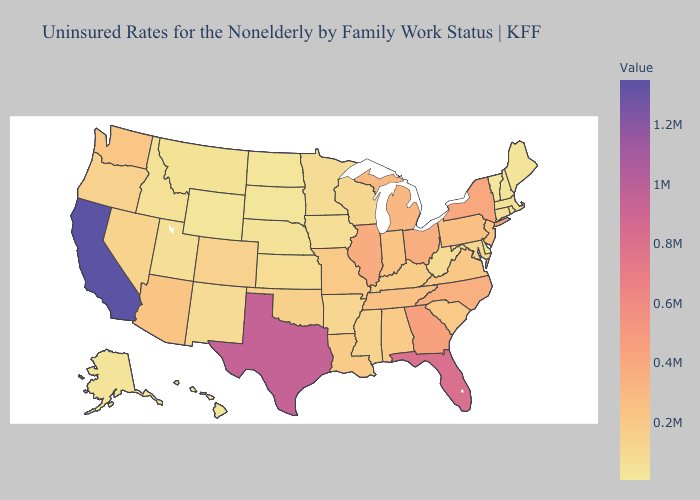Among the states that border New Mexico , which have the highest value?
Quick response, please. Texas. Among the states that border Nebraska , does Iowa have the lowest value?
Concise answer only. No. Does Vermont have the lowest value in the USA?
Be succinct. Yes. Which states have the lowest value in the MidWest?
Keep it brief. North Dakota. Among the states that border Michigan , which have the lowest value?
Keep it brief. Wisconsin. 